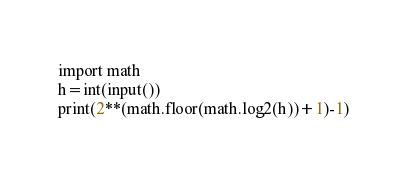Convert code to text. <code><loc_0><loc_0><loc_500><loc_500><_Python_>import math
h=int(input())
print(2**(math.floor(math.log2(h))+1)-1)</code> 